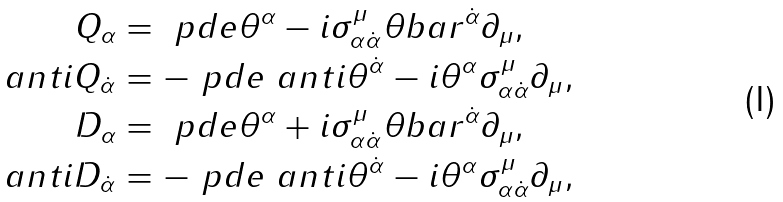<formula> <loc_0><loc_0><loc_500><loc_500>Q _ { \alpha } & = \ p d e { \theta ^ { \alpha } } - i \sigma _ { \alpha \dot { \alpha } } ^ { \mu } \theta b a r ^ { \dot { \alpha } } \partial _ { \mu } , \\ \ a n t i { Q } _ { \dot { \alpha } } & = - \ p d e { \ a n t i { \theta } ^ { \dot { \alpha } } } - i \theta ^ { \alpha } \sigma _ { \alpha \dot { \alpha } } ^ { \mu } \partial _ { \mu } , \\ D _ { \alpha } & = \ p d e { \theta ^ { \alpha } } + i \sigma _ { \alpha \dot { \alpha } } ^ { \mu } \theta b a r ^ { \dot { \alpha } } \partial _ { \mu } , \\ \ a n t i { D } _ { \dot { \alpha } } & = - \ p d e { \ a n t i { \theta } ^ { \dot { \alpha } } } - i \theta ^ { \alpha } \sigma _ { \alpha \dot { \alpha } } ^ { \mu } \partial _ { \mu } ,</formula> 